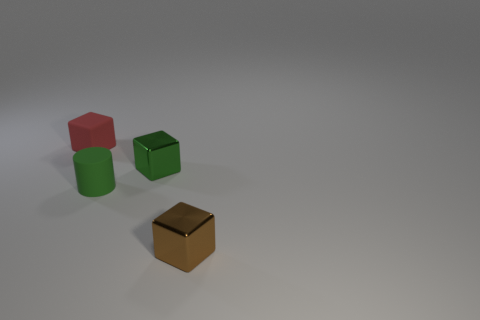What number of tiny metallic cubes are left of the small red rubber block?
Provide a succinct answer. 0. There is a tiny red object that is the same material as the tiny green cylinder; what is its shape?
Make the answer very short. Cube. Do the tiny shiny object that is in front of the tiny green shiny object and the red matte thing have the same shape?
Provide a succinct answer. Yes. How many yellow objects are either tiny metallic cubes or cubes?
Make the answer very short. 0. Are there an equal number of brown metal objects that are behind the small red matte block and small metallic things right of the tiny green block?
Ensure brevity in your answer.  No. The small shiny thing that is left of the cube that is on the right side of the metal thing that is behind the small brown cube is what color?
Provide a succinct answer. Green. Are there any other things that have the same color as the tiny rubber block?
Your answer should be very brief. No. There is a tiny metallic object that is the same color as the cylinder; what is its shape?
Offer a very short reply. Cube. There is a green shiny thing that is the same size as the rubber cube; what is its shape?
Offer a terse response. Cube. Do the small block in front of the rubber cylinder and the red thing that is behind the tiny brown metal object have the same material?
Give a very brief answer. No. 